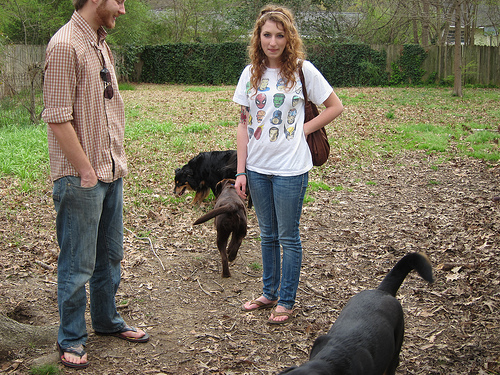<image>
Is the dog next to the person? Yes. The dog is positioned adjacent to the person, located nearby in the same general area. 